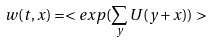Convert formula to latex. <formula><loc_0><loc_0><loc_500><loc_500>w ( t , x ) = < e x p ( \sum _ { y } U ( y + x ) ) ></formula> 